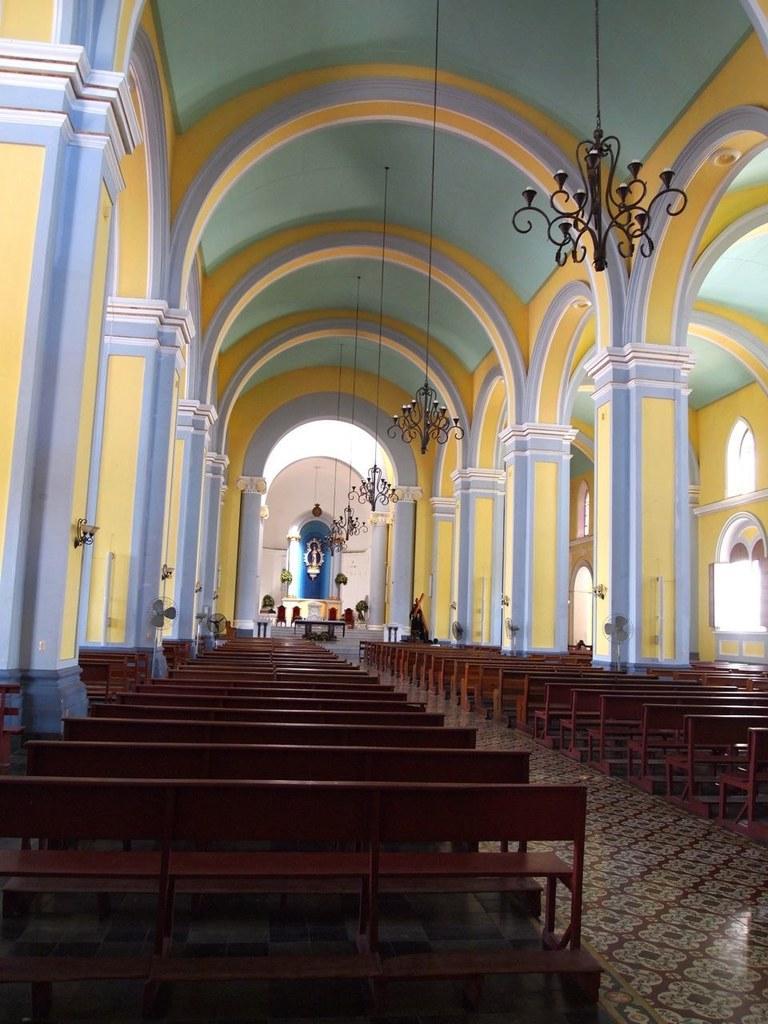Describe this image in one or two sentences. This is an inside view of a church. Here I can see many benches on the floor. On the right and left side of the image there are pillars. In the background there is a table and few chairs placed on the floor. At the top of the image there are few chandeliers hanging to the roof. On the right side there are windows to the wall. 